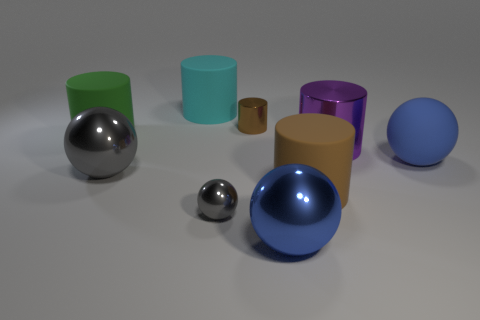Subtract all big cyan rubber cylinders. How many cylinders are left? 4 Subtract all purple cylinders. How many cylinders are left? 4 Subtract 3 cylinders. How many cylinders are left? 2 Subtract all red spheres. Subtract all purple cylinders. How many spheres are left? 4 Subtract all blue blocks. How many blue spheres are left? 2 Subtract all small yellow metal spheres. Subtract all metal spheres. How many objects are left? 6 Add 5 purple cylinders. How many purple cylinders are left? 6 Add 2 shiny balls. How many shiny balls exist? 5 Subtract 2 gray balls. How many objects are left? 7 Subtract all balls. How many objects are left? 5 